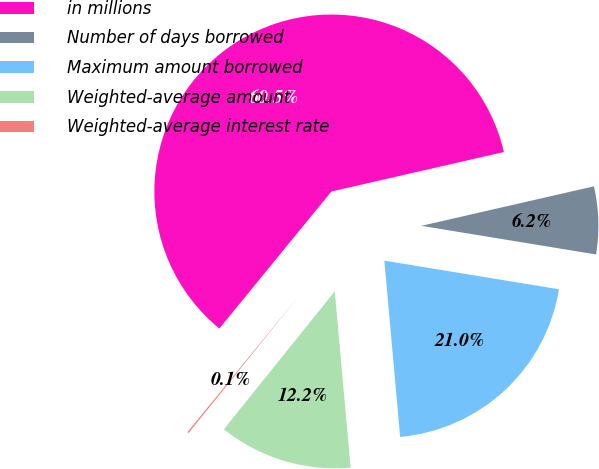<chart> <loc_0><loc_0><loc_500><loc_500><pie_chart><fcel>in millions<fcel>Number of days borrowed<fcel>Maximum amount borrowed<fcel>Weighted-average amount<fcel>Weighted-average interest rate<nl><fcel>60.51%<fcel>6.17%<fcel>20.99%<fcel>12.2%<fcel>0.13%<nl></chart> 